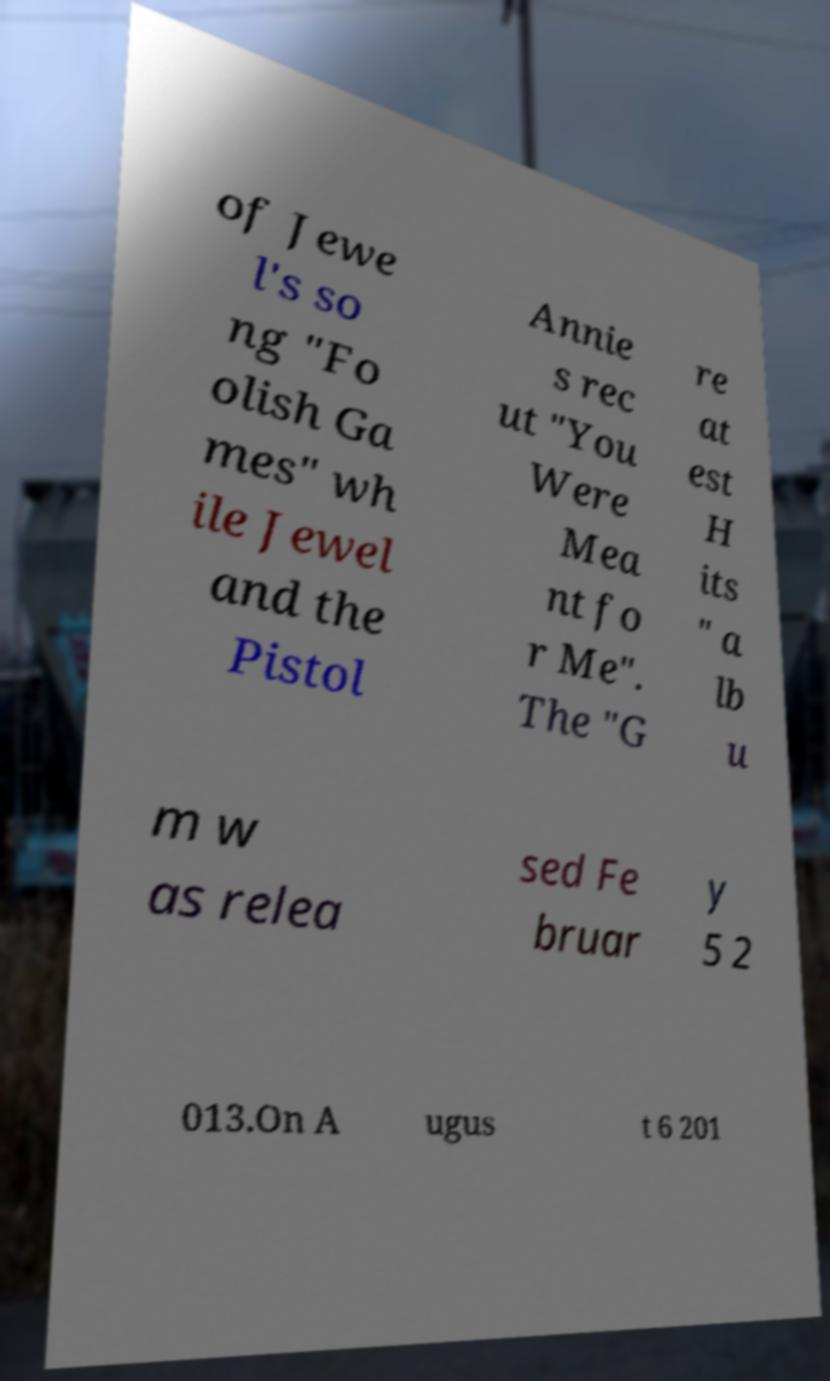Please read and relay the text visible in this image. What does it say? of Jewe l's so ng "Fo olish Ga mes" wh ile Jewel and the Pistol Annie s rec ut "You Were Mea nt fo r Me". The "G re at est H its " a lb u m w as relea sed Fe bruar y 5 2 013.On A ugus t 6 201 